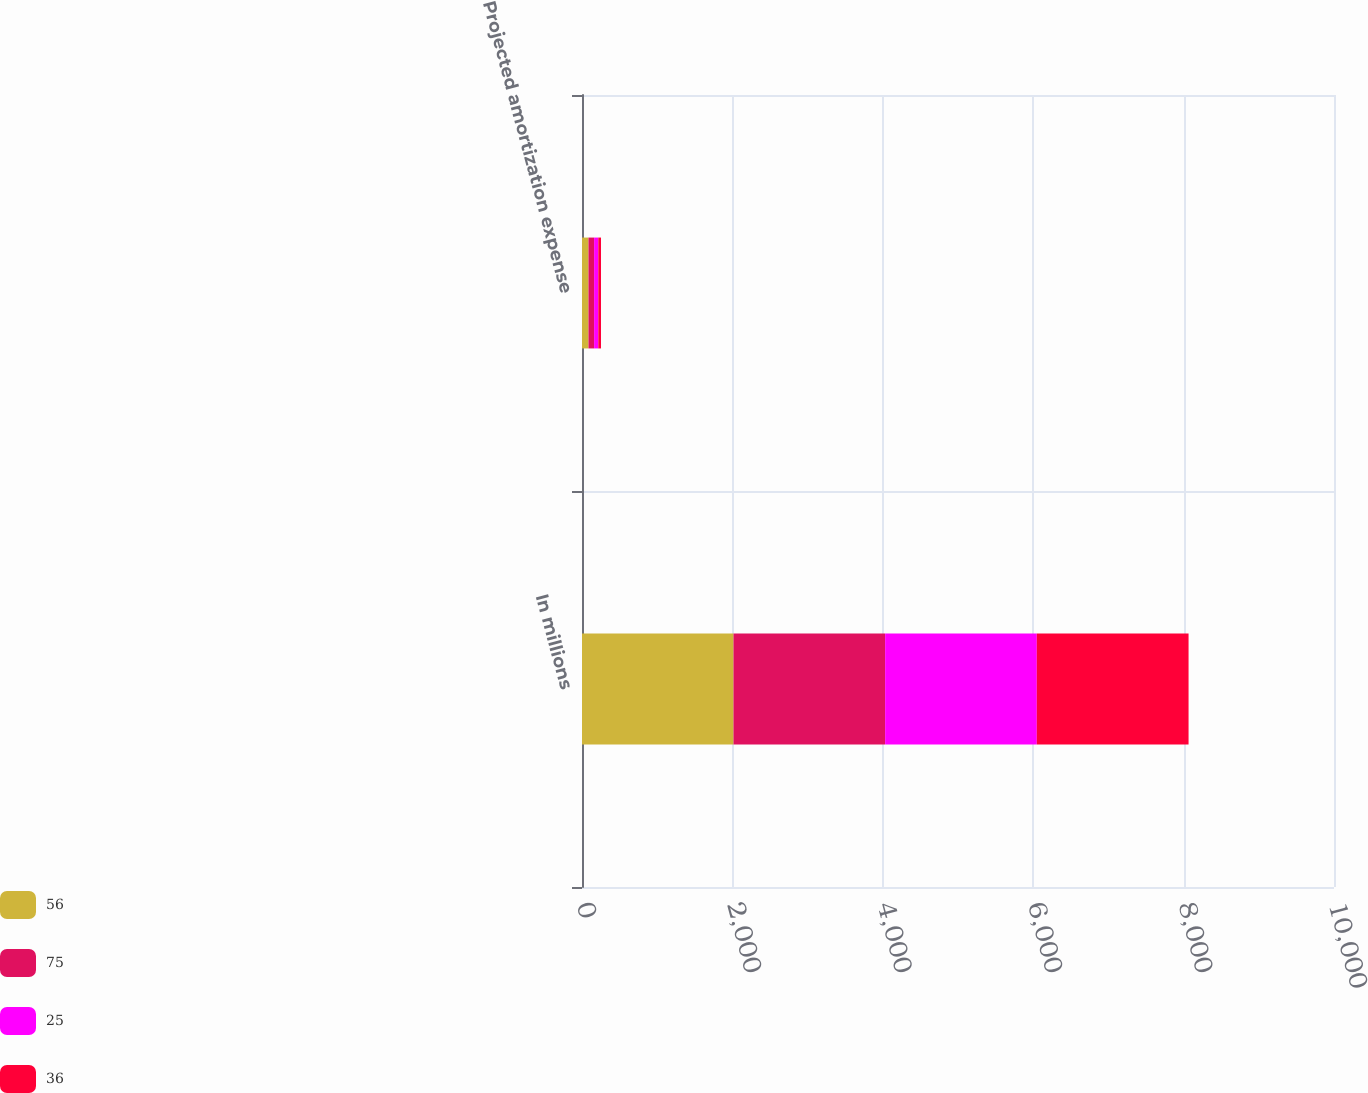Convert chart. <chart><loc_0><loc_0><loc_500><loc_500><stacked_bar_chart><ecel><fcel>In millions<fcel>Projected amortization expense<nl><fcel>56<fcel>2015<fcel>86<nl><fcel>75<fcel>2016<fcel>75<nl><fcel>25<fcel>2017<fcel>56<nl><fcel>36<fcel>2018<fcel>36<nl></chart> 